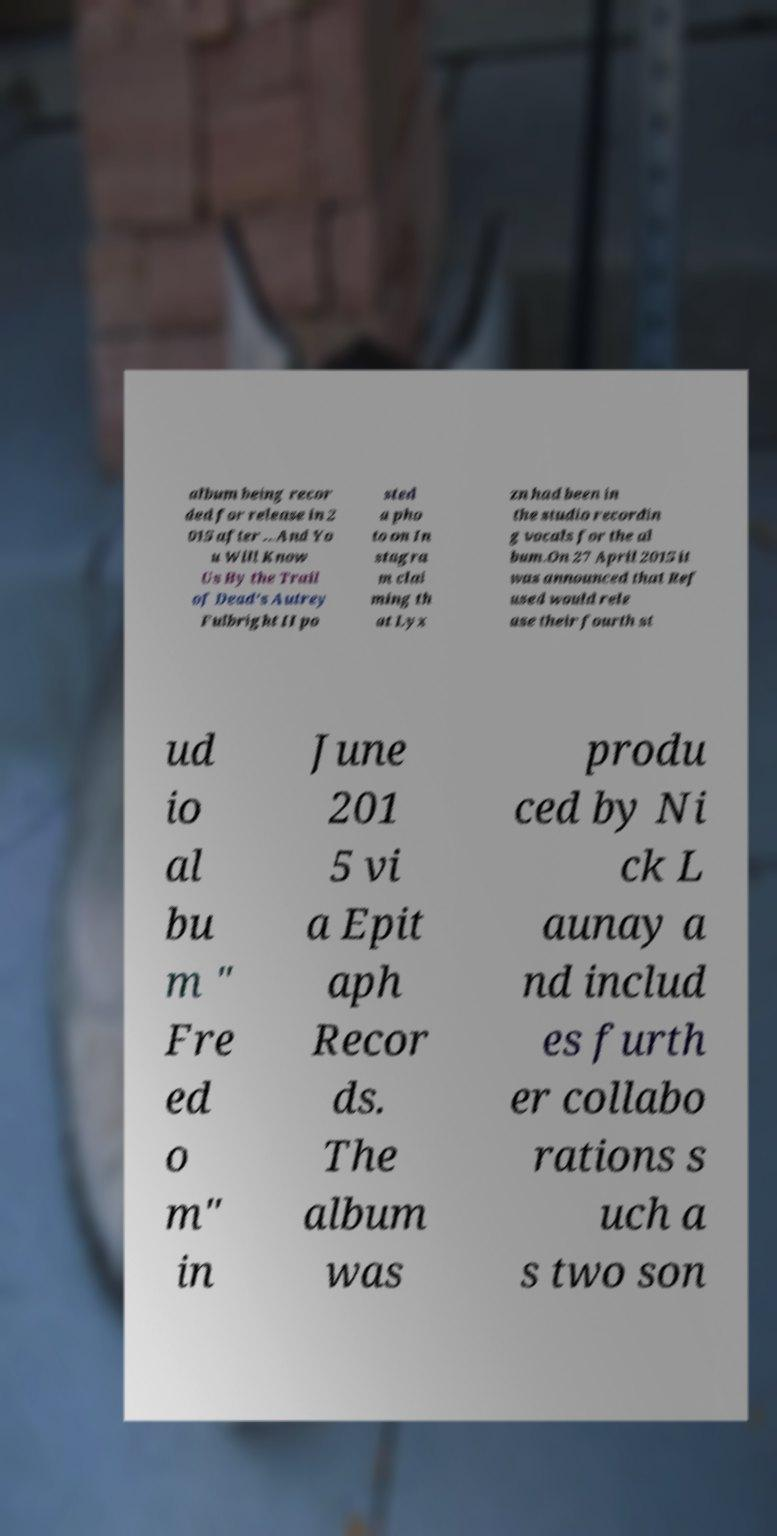For documentation purposes, I need the text within this image transcribed. Could you provide that? album being recor ded for release in 2 015 after ...And Yo u Will Know Us By the Trail of Dead's Autrey Fulbright II po sted a pho to on In stagra m clai ming th at Lyx zn had been in the studio recordin g vocals for the al bum.On 27 April 2015 it was announced that Ref used would rele ase their fourth st ud io al bu m " Fre ed o m" in June 201 5 vi a Epit aph Recor ds. The album was produ ced by Ni ck L aunay a nd includ es furth er collabo rations s uch a s two son 